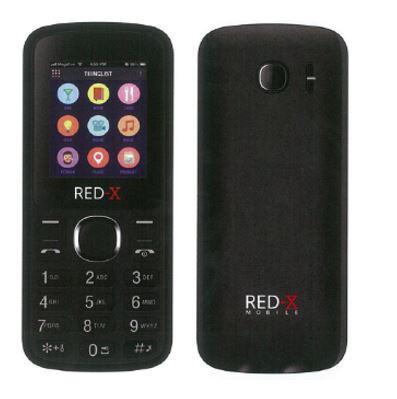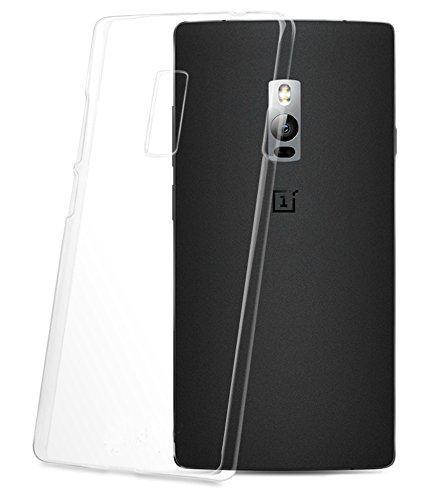The first image is the image on the left, the second image is the image on the right. Examine the images to the left and right. Is the description "The image on the left shows a screen protector hovering over a phone." accurate? Answer yes or no. No. 